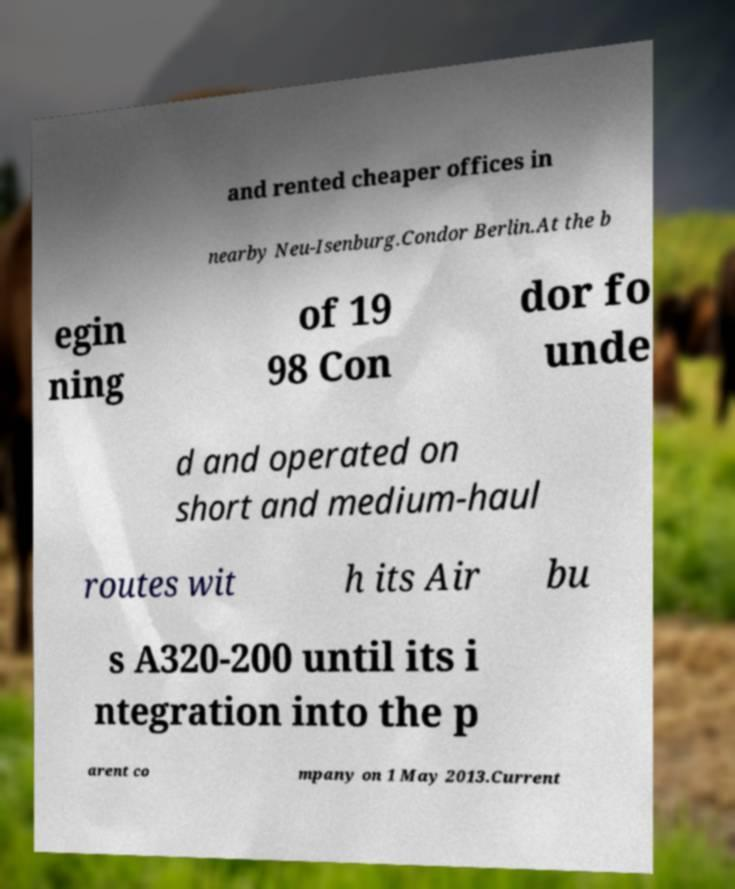Please identify and transcribe the text found in this image. and rented cheaper offices in nearby Neu-Isenburg.Condor Berlin.At the b egin ning of 19 98 Con dor fo unde d and operated on short and medium-haul routes wit h its Air bu s A320-200 until its i ntegration into the p arent co mpany on 1 May 2013.Current 